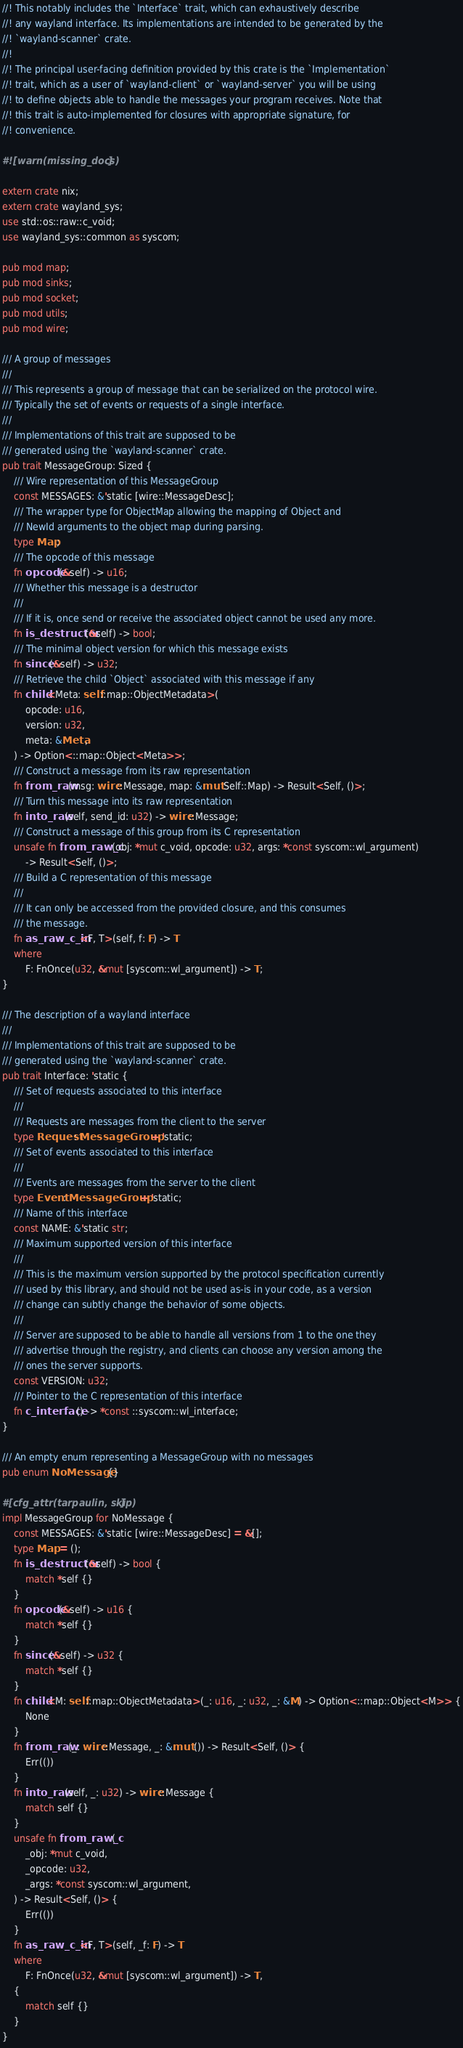Convert code to text. <code><loc_0><loc_0><loc_500><loc_500><_Rust_>//! This notably includes the `Interface` trait, which can exhaustively describe
//! any wayland interface. Its implementations are intended to be generated by the
//! `wayland-scanner` crate.
//!
//! The principal user-facing definition provided by this crate is the `Implementation`
//! trait, which as a user of `wayland-client` or `wayland-server` you will be using
//! to define objects able to handle the messages your program receives. Note that
//! this trait is auto-implemented for closures with appropriate signature, for
//! convenience.

#![warn(missing_docs)]

extern crate nix;
extern crate wayland_sys;
use std::os::raw::c_void;
use wayland_sys::common as syscom;

pub mod map;
pub mod sinks;
pub mod socket;
pub mod utils;
pub mod wire;

/// A group of messages
///
/// This represents a group of message that can be serialized on the protocol wire.
/// Typically the set of events or requests of a single interface.
///
/// Implementations of this trait are supposed to be
/// generated using the `wayland-scanner` crate.
pub trait MessageGroup: Sized {
    /// Wire representation of this MessageGroup
    const MESSAGES: &'static [wire::MessageDesc];
    /// The wrapper type for ObjectMap allowing the mapping of Object and
    /// NewId arguments to the object map during parsing.
    type Map;
    /// The opcode of this message
    fn opcode(&self) -> u16;
    /// Whether this message is a destructor
    ///
    /// If it is, once send or receive the associated object cannot be used any more.
    fn is_destructor(&self) -> bool;
    /// The minimal object version for which this message exists
    fn since(&self) -> u32;
    /// Retrieve the child `Object` associated with this message if any
    fn child<Meta: self::map::ObjectMetadata>(
        opcode: u16,
        version: u32,
        meta: &Meta,
    ) -> Option<::map::Object<Meta>>;
    /// Construct a message from its raw representation
    fn from_raw(msg: wire::Message, map: &mut Self::Map) -> Result<Self, ()>;
    /// Turn this message into its raw representation
    fn into_raw(self, send_id: u32) -> wire::Message;
    /// Construct a message of this group from its C representation
    unsafe fn from_raw_c(obj: *mut c_void, opcode: u32, args: *const syscom::wl_argument)
        -> Result<Self, ()>;
    /// Build a C representation of this message
    ///
    /// It can only be accessed from the provided closure, and this consumes
    /// the message.
    fn as_raw_c_in<F, T>(self, f: F) -> T
    where
        F: FnOnce(u32, &mut [syscom::wl_argument]) -> T;
}

/// The description of a wayland interface
///
/// Implementations of this trait are supposed to be
/// generated using the `wayland-scanner` crate.
pub trait Interface: 'static {
    /// Set of requests associated to this interface
    ///
    /// Requests are messages from the client to the server
    type Request: MessageGroup + 'static;
    /// Set of events associated to this interface
    ///
    /// Events are messages from the server to the client
    type Event: MessageGroup + 'static;
    /// Name of this interface
    const NAME: &'static str;
    /// Maximum supported version of this interface
    ///
    /// This is the maximum version supported by the protocol specification currently
    /// used by this library, and should not be used as-is in your code, as a version
    /// change can subtly change the behavior of some objects.
    ///
    /// Server are supposed to be able to handle all versions from 1 to the one they
    /// advertise through the registry, and clients can choose any version among the
    /// ones the server supports.
    const VERSION: u32;
    /// Pointer to the C representation of this interface
    fn c_interface() -> *const ::syscom::wl_interface;
}

/// An empty enum representing a MessageGroup with no messages
pub enum NoMessage {}

#[cfg_attr(tarpaulin, skip)]
impl MessageGroup for NoMessage {
    const MESSAGES: &'static [wire::MessageDesc] = &[];
    type Map = ();
    fn is_destructor(&self) -> bool {
        match *self {}
    }
    fn opcode(&self) -> u16 {
        match *self {}
    }
    fn since(&self) -> u32 {
        match *self {}
    }
    fn child<M: self::map::ObjectMetadata>(_: u16, _: u32, _: &M) -> Option<::map::Object<M>> {
        None
    }
    fn from_raw(_: wire::Message, _: &mut ()) -> Result<Self, ()> {
        Err(())
    }
    fn into_raw(self, _: u32) -> wire::Message {
        match self {}
    }
    unsafe fn from_raw_c(
        _obj: *mut c_void,
        _opcode: u32,
        _args: *const syscom::wl_argument,
    ) -> Result<Self, ()> {
        Err(())
    }
    fn as_raw_c_in<F, T>(self, _f: F) -> T
    where
        F: FnOnce(u32, &mut [syscom::wl_argument]) -> T,
    {
        match self {}
    }
}
</code> 